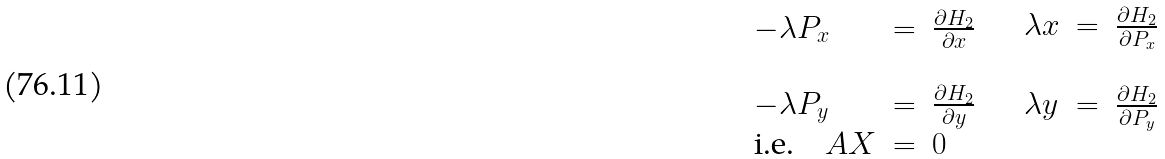Convert formula to latex. <formula><loc_0><loc_0><loc_500><loc_500>\begin{array} { l c l } - \lambda P _ { x } & = & \frac { \partial { H _ { 2 } } } { \partial x } \\ & & \\ - \lambda P _ { y } & = & \frac { \partial { H _ { 2 } } } { \partial y } \\ \text {i.e.} \quad A X & = & 0 \end{array} \quad \begin{array} { l c l } \lambda x & = & \frac { \partial { H _ { 2 } } } { \partial P _ { x } } \\ & & \\ \lambda y & = & \frac { \partial { H _ { 2 } } } { \partial P _ { y } } \\ & & \end{array}</formula> 